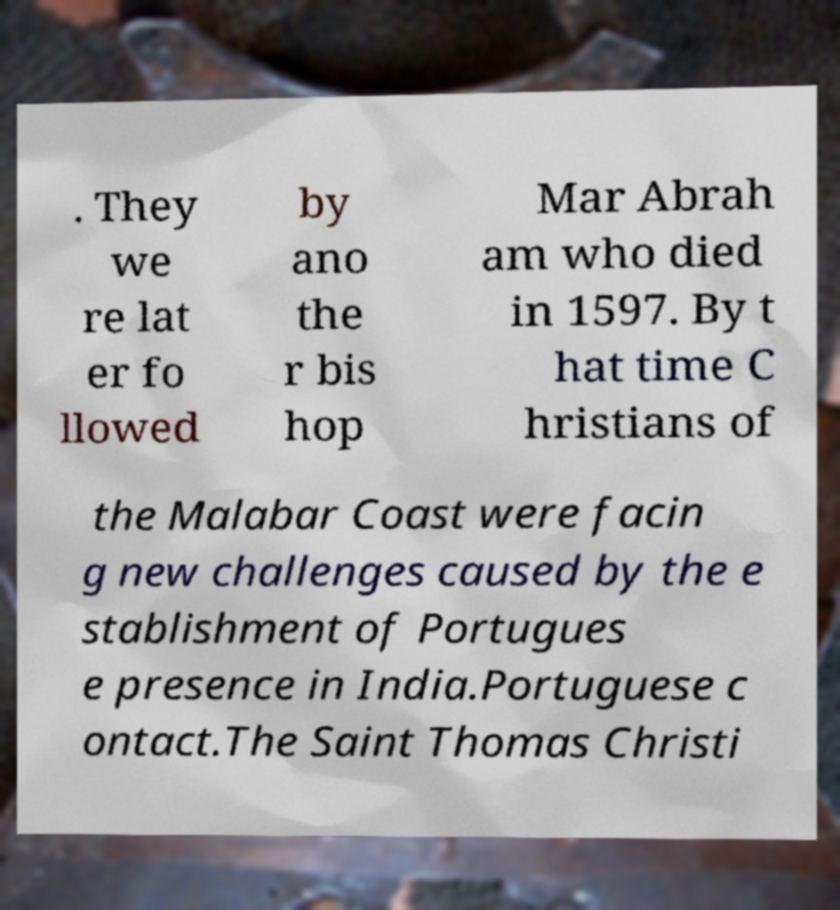Can you accurately transcribe the text from the provided image for me? . They we re lat er fo llowed by ano the r bis hop Mar Abrah am who died in 1597. By t hat time C hristians of the Malabar Coast were facin g new challenges caused by the e stablishment of Portugues e presence in India.Portuguese c ontact.The Saint Thomas Christi 